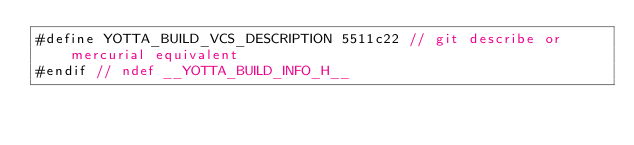<code> <loc_0><loc_0><loc_500><loc_500><_C_>#define YOTTA_BUILD_VCS_DESCRIPTION 5511c22 // git describe or mercurial equivalent
#endif // ndef __YOTTA_BUILD_INFO_H__
</code> 